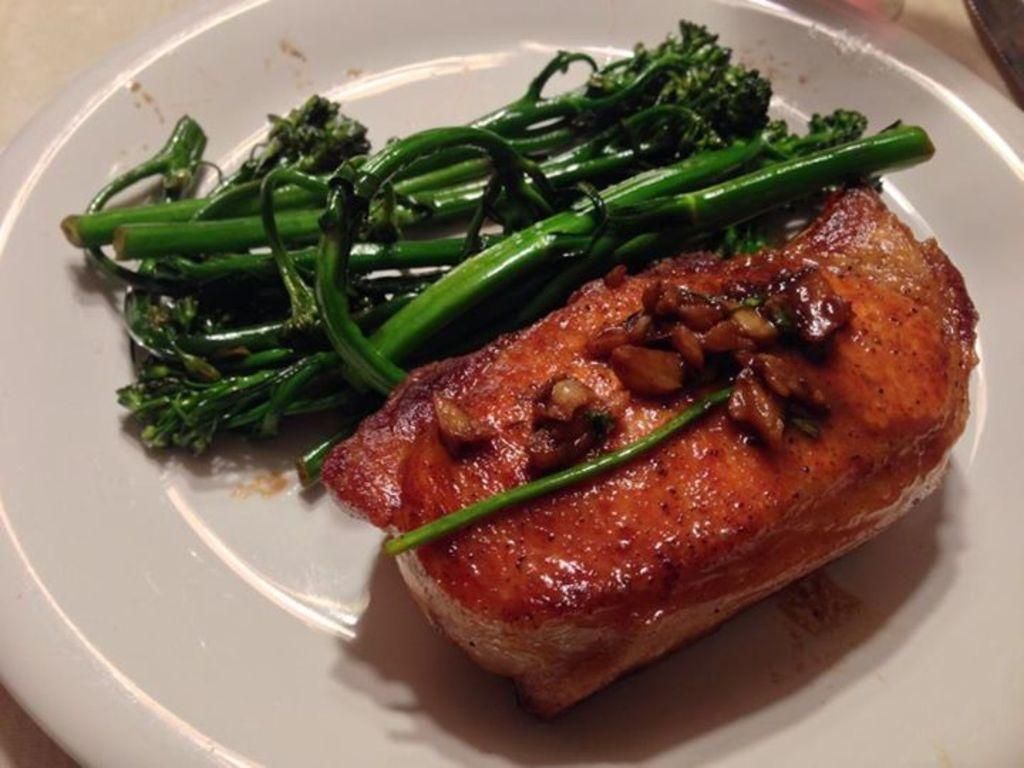What color is the plate in the image? The plate in the image is white in color. What types of food items are on the plate? There are two different food items on the plate, one green and one red. Can you describe the colors of the food items on the plate? One food item is green in color, and the other is red in color. What type of brass material is used to make the stove in the image? There is no stove present in the image, so it is not possible to determine the type of brass material used. 